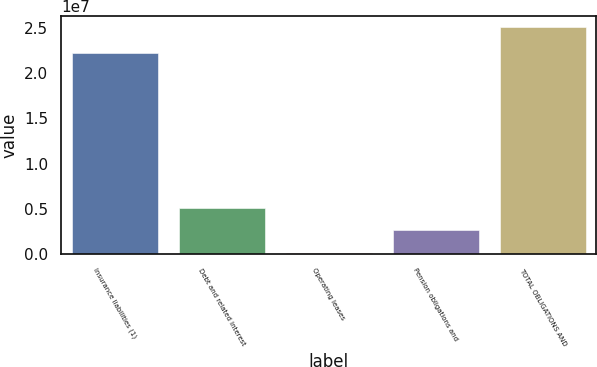<chart> <loc_0><loc_0><loc_500><loc_500><bar_chart><fcel>Insurance liabilities (1)<fcel>Debt and related interest<fcel>Operating leases<fcel>Pension obligations and<fcel>TOTAL OBLIGATIONS AND<nl><fcel>2.22172e+07<fcel>5.11166e+06<fcel>126251<fcel>2.61896e+06<fcel>2.50533e+07<nl></chart> 